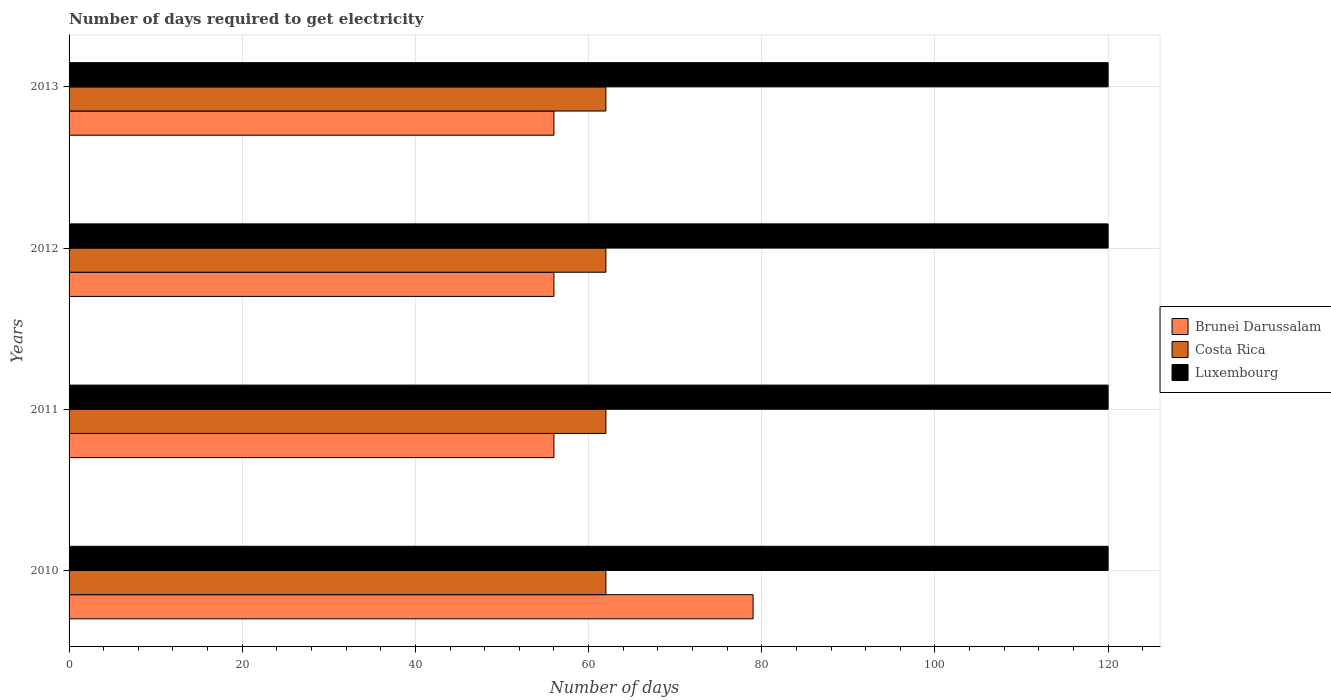How many different coloured bars are there?
Offer a very short reply. 3. Are the number of bars on each tick of the Y-axis equal?
Keep it short and to the point. Yes. How many bars are there on the 3rd tick from the bottom?
Your answer should be compact. 3. What is the label of the 1st group of bars from the top?
Keep it short and to the point. 2013. In how many cases, is the number of bars for a given year not equal to the number of legend labels?
Your answer should be very brief. 0. What is the number of days required to get electricity in in Luxembourg in 2012?
Provide a short and direct response. 120. Across all years, what is the maximum number of days required to get electricity in in Costa Rica?
Offer a very short reply. 62. Across all years, what is the minimum number of days required to get electricity in in Luxembourg?
Make the answer very short. 120. What is the total number of days required to get electricity in in Costa Rica in the graph?
Make the answer very short. 248. What is the difference between the number of days required to get electricity in in Brunei Darussalam in 2012 and that in 2013?
Provide a succinct answer. 0. What is the difference between the number of days required to get electricity in in Luxembourg in 2011 and the number of days required to get electricity in in Costa Rica in 2013?
Your response must be concise. 58. In the year 2010, what is the difference between the number of days required to get electricity in in Costa Rica and number of days required to get electricity in in Brunei Darussalam?
Provide a succinct answer. -17. In how many years, is the number of days required to get electricity in in Costa Rica greater than 40 days?
Ensure brevity in your answer.  4. Is the difference between the number of days required to get electricity in in Costa Rica in 2010 and 2013 greater than the difference between the number of days required to get electricity in in Brunei Darussalam in 2010 and 2013?
Your answer should be very brief. No. In how many years, is the number of days required to get electricity in in Costa Rica greater than the average number of days required to get electricity in in Costa Rica taken over all years?
Offer a very short reply. 0. Is the sum of the number of days required to get electricity in in Brunei Darussalam in 2010 and 2013 greater than the maximum number of days required to get electricity in in Costa Rica across all years?
Keep it short and to the point. Yes. What does the 1st bar from the top in 2011 represents?
Your answer should be very brief. Luxembourg. What does the 3rd bar from the bottom in 2012 represents?
Provide a short and direct response. Luxembourg. How many bars are there?
Your answer should be compact. 12. Are the values on the major ticks of X-axis written in scientific E-notation?
Offer a terse response. No. Does the graph contain any zero values?
Give a very brief answer. No. How many legend labels are there?
Make the answer very short. 3. How are the legend labels stacked?
Your answer should be very brief. Vertical. What is the title of the graph?
Make the answer very short. Number of days required to get electricity. What is the label or title of the X-axis?
Offer a very short reply. Number of days. What is the Number of days of Brunei Darussalam in 2010?
Your answer should be very brief. 79. What is the Number of days of Costa Rica in 2010?
Offer a very short reply. 62. What is the Number of days in Luxembourg in 2010?
Ensure brevity in your answer.  120. What is the Number of days of Costa Rica in 2011?
Provide a short and direct response. 62. What is the Number of days of Luxembourg in 2011?
Ensure brevity in your answer.  120. What is the Number of days of Luxembourg in 2012?
Provide a succinct answer. 120. What is the Number of days in Brunei Darussalam in 2013?
Give a very brief answer. 56. What is the Number of days of Luxembourg in 2013?
Provide a succinct answer. 120. Across all years, what is the maximum Number of days of Brunei Darussalam?
Your answer should be compact. 79. Across all years, what is the maximum Number of days of Luxembourg?
Provide a succinct answer. 120. Across all years, what is the minimum Number of days of Brunei Darussalam?
Make the answer very short. 56. Across all years, what is the minimum Number of days in Luxembourg?
Your answer should be very brief. 120. What is the total Number of days in Brunei Darussalam in the graph?
Your answer should be compact. 247. What is the total Number of days in Costa Rica in the graph?
Provide a succinct answer. 248. What is the total Number of days of Luxembourg in the graph?
Offer a terse response. 480. What is the difference between the Number of days in Brunei Darussalam in 2010 and that in 2011?
Make the answer very short. 23. What is the difference between the Number of days of Luxembourg in 2010 and that in 2011?
Provide a short and direct response. 0. What is the difference between the Number of days in Luxembourg in 2010 and that in 2012?
Ensure brevity in your answer.  0. What is the difference between the Number of days in Luxembourg in 2010 and that in 2013?
Provide a short and direct response. 0. What is the difference between the Number of days in Costa Rica in 2011 and that in 2012?
Offer a very short reply. 0. What is the difference between the Number of days in Luxembourg in 2011 and that in 2012?
Your answer should be compact. 0. What is the difference between the Number of days in Brunei Darussalam in 2011 and that in 2013?
Keep it short and to the point. 0. What is the difference between the Number of days of Luxembourg in 2011 and that in 2013?
Make the answer very short. 0. What is the difference between the Number of days in Brunei Darussalam in 2012 and that in 2013?
Offer a very short reply. 0. What is the difference between the Number of days in Costa Rica in 2012 and that in 2013?
Your answer should be compact. 0. What is the difference between the Number of days of Brunei Darussalam in 2010 and the Number of days of Costa Rica in 2011?
Give a very brief answer. 17. What is the difference between the Number of days of Brunei Darussalam in 2010 and the Number of days of Luxembourg in 2011?
Your response must be concise. -41. What is the difference between the Number of days of Costa Rica in 2010 and the Number of days of Luxembourg in 2011?
Give a very brief answer. -58. What is the difference between the Number of days in Brunei Darussalam in 2010 and the Number of days in Costa Rica in 2012?
Offer a very short reply. 17. What is the difference between the Number of days in Brunei Darussalam in 2010 and the Number of days in Luxembourg in 2012?
Keep it short and to the point. -41. What is the difference between the Number of days of Costa Rica in 2010 and the Number of days of Luxembourg in 2012?
Give a very brief answer. -58. What is the difference between the Number of days of Brunei Darussalam in 2010 and the Number of days of Luxembourg in 2013?
Provide a short and direct response. -41. What is the difference between the Number of days in Costa Rica in 2010 and the Number of days in Luxembourg in 2013?
Your response must be concise. -58. What is the difference between the Number of days in Brunei Darussalam in 2011 and the Number of days in Luxembourg in 2012?
Your response must be concise. -64. What is the difference between the Number of days in Costa Rica in 2011 and the Number of days in Luxembourg in 2012?
Make the answer very short. -58. What is the difference between the Number of days in Brunei Darussalam in 2011 and the Number of days in Luxembourg in 2013?
Your answer should be very brief. -64. What is the difference between the Number of days in Costa Rica in 2011 and the Number of days in Luxembourg in 2013?
Your response must be concise. -58. What is the difference between the Number of days in Brunei Darussalam in 2012 and the Number of days in Costa Rica in 2013?
Offer a terse response. -6. What is the difference between the Number of days of Brunei Darussalam in 2012 and the Number of days of Luxembourg in 2013?
Provide a short and direct response. -64. What is the difference between the Number of days of Costa Rica in 2012 and the Number of days of Luxembourg in 2013?
Keep it short and to the point. -58. What is the average Number of days of Brunei Darussalam per year?
Make the answer very short. 61.75. What is the average Number of days of Luxembourg per year?
Make the answer very short. 120. In the year 2010, what is the difference between the Number of days of Brunei Darussalam and Number of days of Luxembourg?
Your response must be concise. -41. In the year 2010, what is the difference between the Number of days of Costa Rica and Number of days of Luxembourg?
Offer a very short reply. -58. In the year 2011, what is the difference between the Number of days of Brunei Darussalam and Number of days of Luxembourg?
Offer a very short reply. -64. In the year 2011, what is the difference between the Number of days of Costa Rica and Number of days of Luxembourg?
Offer a very short reply. -58. In the year 2012, what is the difference between the Number of days of Brunei Darussalam and Number of days of Luxembourg?
Give a very brief answer. -64. In the year 2012, what is the difference between the Number of days of Costa Rica and Number of days of Luxembourg?
Give a very brief answer. -58. In the year 2013, what is the difference between the Number of days in Brunei Darussalam and Number of days in Costa Rica?
Make the answer very short. -6. In the year 2013, what is the difference between the Number of days in Brunei Darussalam and Number of days in Luxembourg?
Your answer should be very brief. -64. In the year 2013, what is the difference between the Number of days of Costa Rica and Number of days of Luxembourg?
Make the answer very short. -58. What is the ratio of the Number of days in Brunei Darussalam in 2010 to that in 2011?
Your answer should be compact. 1.41. What is the ratio of the Number of days in Costa Rica in 2010 to that in 2011?
Make the answer very short. 1. What is the ratio of the Number of days of Brunei Darussalam in 2010 to that in 2012?
Offer a terse response. 1.41. What is the ratio of the Number of days of Costa Rica in 2010 to that in 2012?
Offer a very short reply. 1. What is the ratio of the Number of days of Brunei Darussalam in 2010 to that in 2013?
Provide a short and direct response. 1.41. What is the ratio of the Number of days of Brunei Darussalam in 2011 to that in 2012?
Your answer should be compact. 1. What is the ratio of the Number of days in Luxembourg in 2011 to that in 2012?
Your answer should be compact. 1. What is the ratio of the Number of days of Brunei Darussalam in 2011 to that in 2013?
Provide a succinct answer. 1. What is the ratio of the Number of days in Brunei Darussalam in 2012 to that in 2013?
Offer a terse response. 1. What is the ratio of the Number of days of Luxembourg in 2012 to that in 2013?
Keep it short and to the point. 1. What is the difference between the highest and the second highest Number of days of Costa Rica?
Provide a succinct answer. 0. What is the difference between the highest and the second highest Number of days in Luxembourg?
Your answer should be very brief. 0. What is the difference between the highest and the lowest Number of days of Luxembourg?
Make the answer very short. 0. 